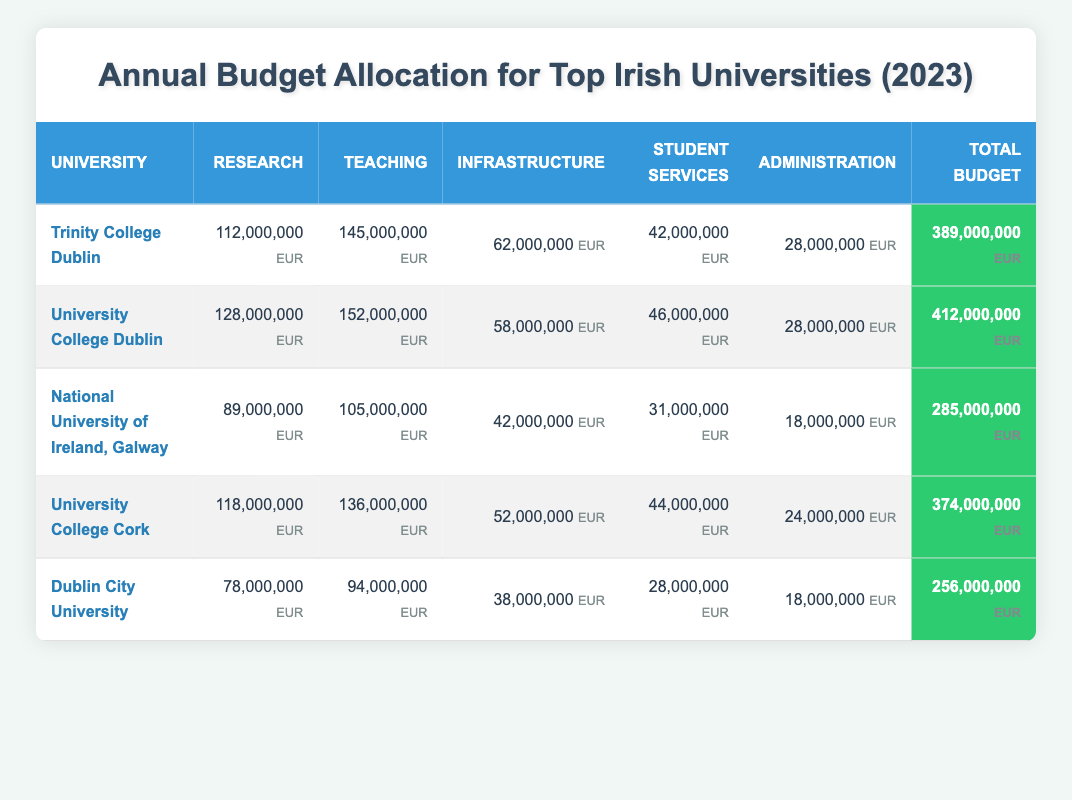What is the total budget for University College Dublin? The total budget for University College Dublin is explicitly stated in the table under the total budget column, which is 412,000,000 EUR.
Answer: 412,000,000 EUR Which university has the highest allocation for research? By comparing the research allocation for all universities listed, we see that University College Dublin has the highest research allocation of 128,000,000 EUR.
Answer: University College Dublin What is the combined total budget for Trinity College Dublin and University College Cork? To find the combined total budget, add the total budgets of Trinity College Dublin (389,000,000 EUR) and University College Cork (374,000,000 EUR): 389,000,000 + 374,000,000 = 763,000,000 EUR.
Answer: 763,000,000 EUR Is the total budget for Dublin City University greater than the combined research allocations of National University of Ireland, Galway and University College Cork? The total budget for Dublin City University is 256,000,000 EUR. The combined research allocations are 89,000,000 EUR (NUIG) + 118,000,000 EUR (UCC) = 207,000,000 EUR. Since 256,000,000 EUR is greater than 207,000,000 EUR, the answer is true.
Answer: Yes What percentage of the total budget for National University of Ireland, Galway is allocated to student services? To find this percentage, first identify the student services allocation of 31,000,000 EUR and the total budget of 285,000,000 EUR. The percentage is calculated as (31,000,000 / 285,000,000) * 100 ≈ 10.88%.
Answer: Approximately 10.88% 